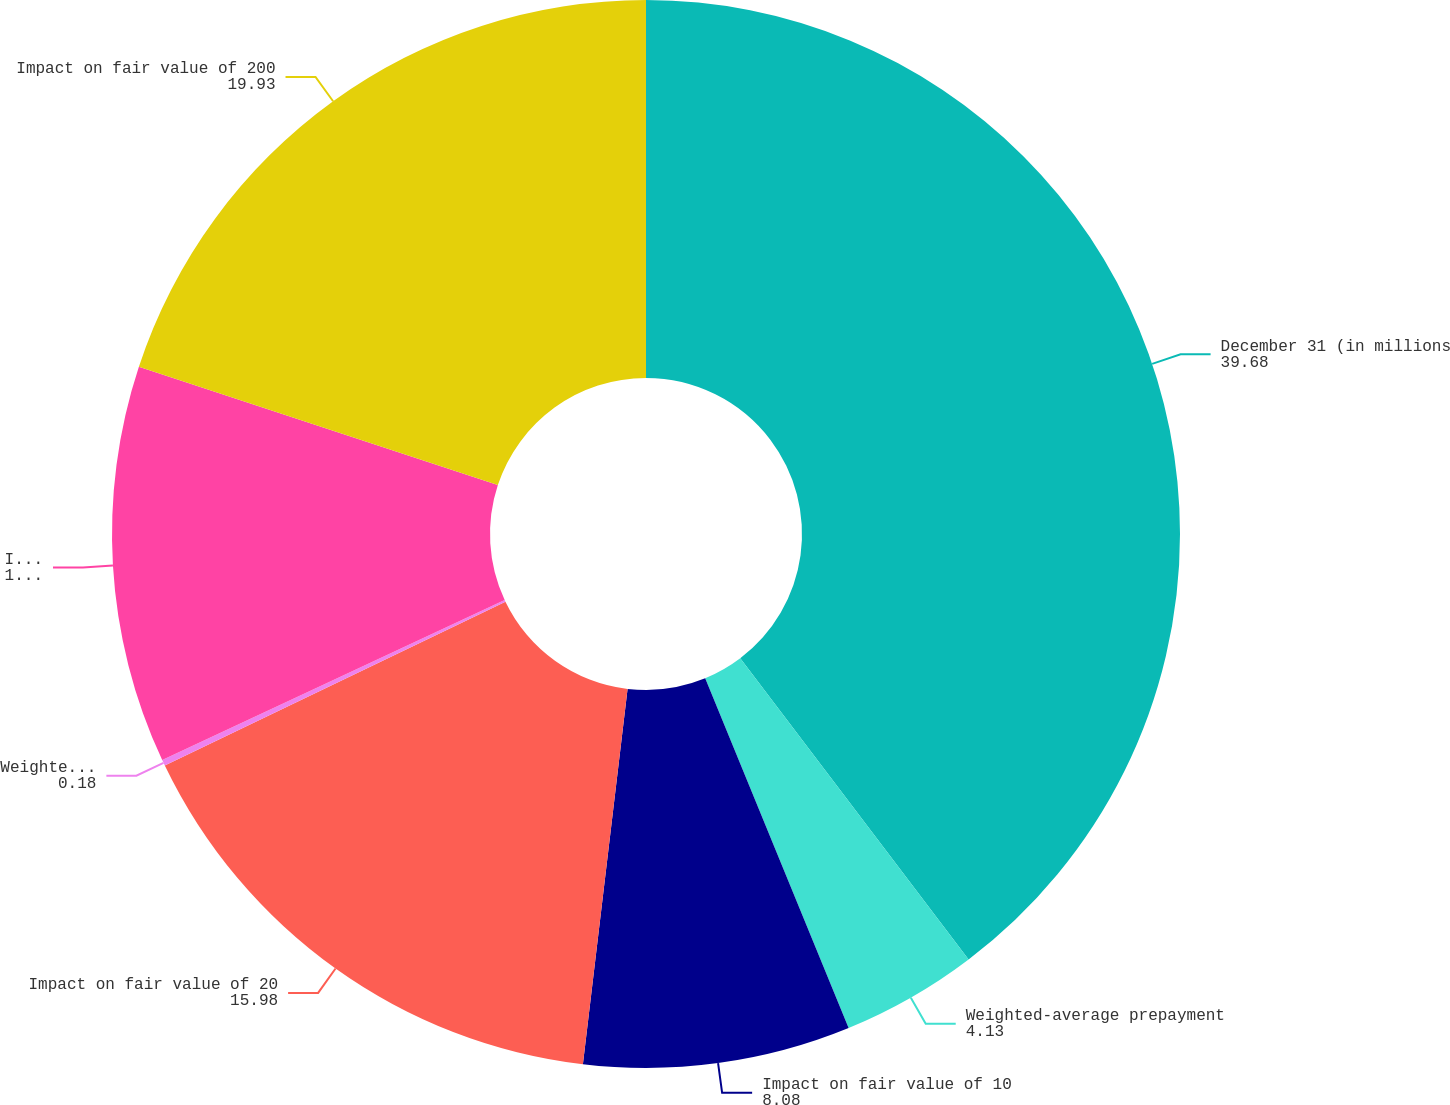<chart> <loc_0><loc_0><loc_500><loc_500><pie_chart><fcel>December 31 (in millions<fcel>Weighted-average prepayment<fcel>Impact on fair value of 10<fcel>Impact on fair value of 20<fcel>Weighted-average option<fcel>Impact on fair value of 100<fcel>Impact on fair value of 200<nl><fcel>39.68%<fcel>4.13%<fcel>8.08%<fcel>15.98%<fcel>0.18%<fcel>12.03%<fcel>19.93%<nl></chart> 